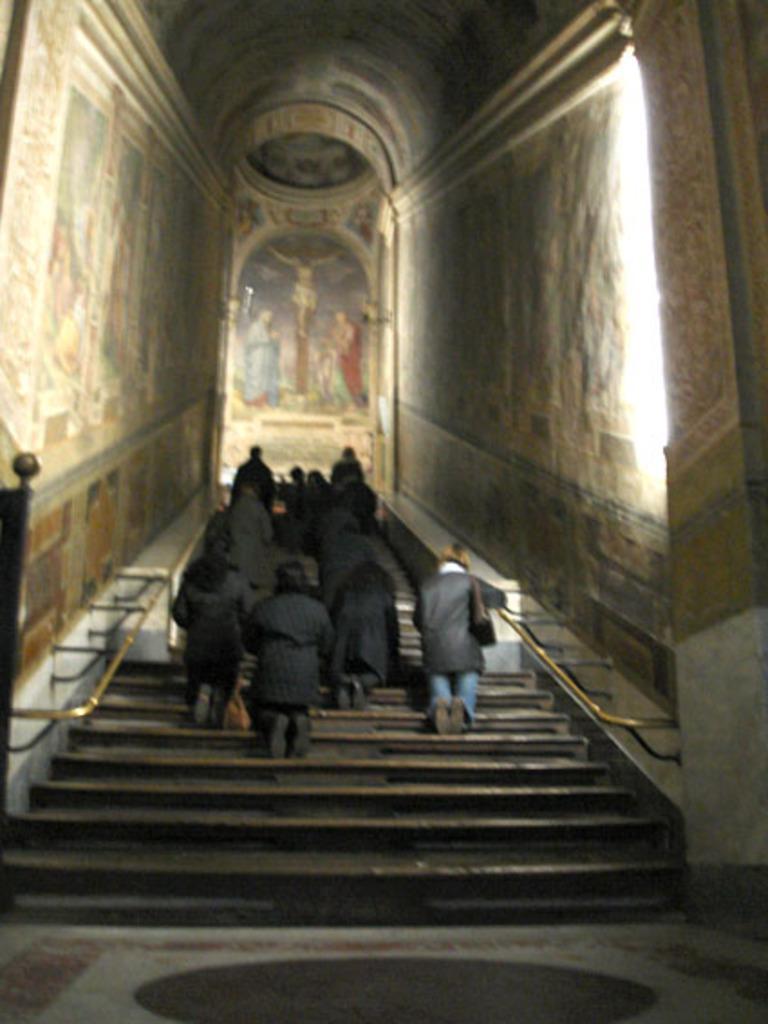Could you give a brief overview of what you see in this image? There is a group of persons in black color dresses kneeling down on the steps of a building. Which is having walls. In the background, there is a painting on the wall and there is roof. 